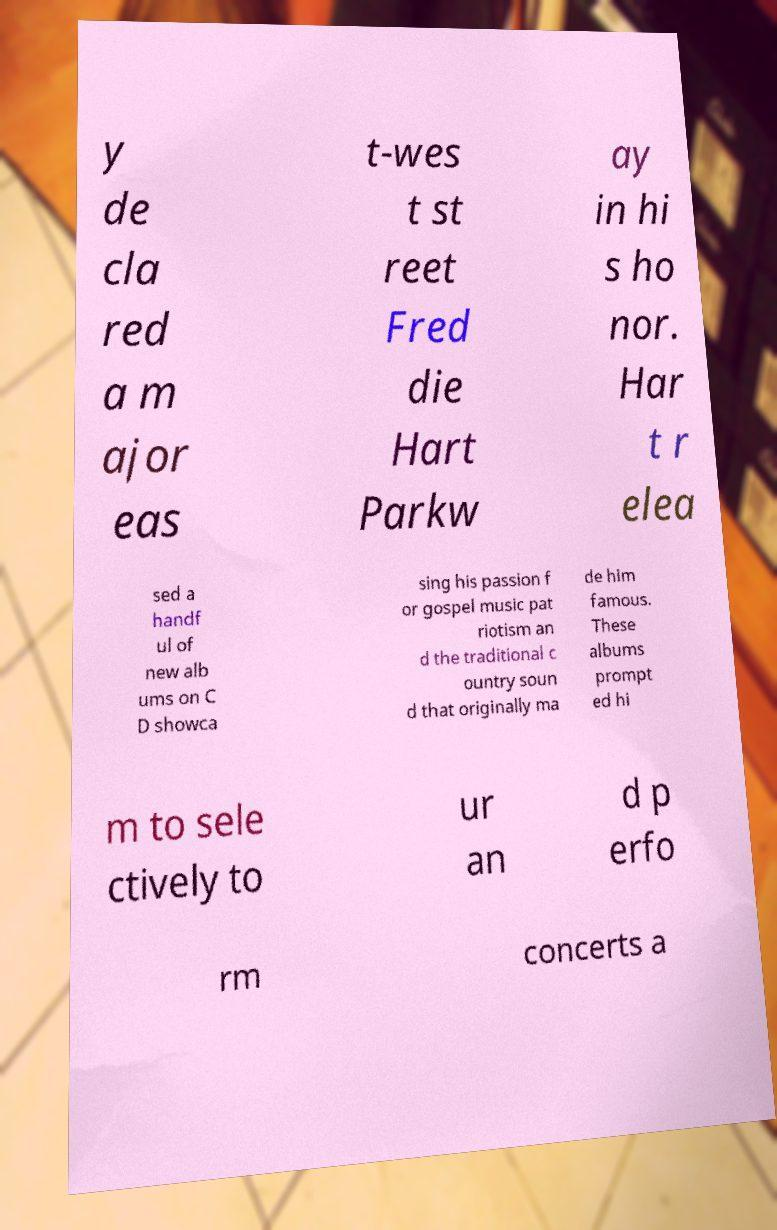Please identify and transcribe the text found in this image. y de cla red a m ajor eas t-wes t st reet Fred die Hart Parkw ay in hi s ho nor. Har t r elea sed a handf ul of new alb ums on C D showca sing his passion f or gospel music pat riotism an d the traditional c ountry soun d that originally ma de him famous. These albums prompt ed hi m to sele ctively to ur an d p erfo rm concerts a 